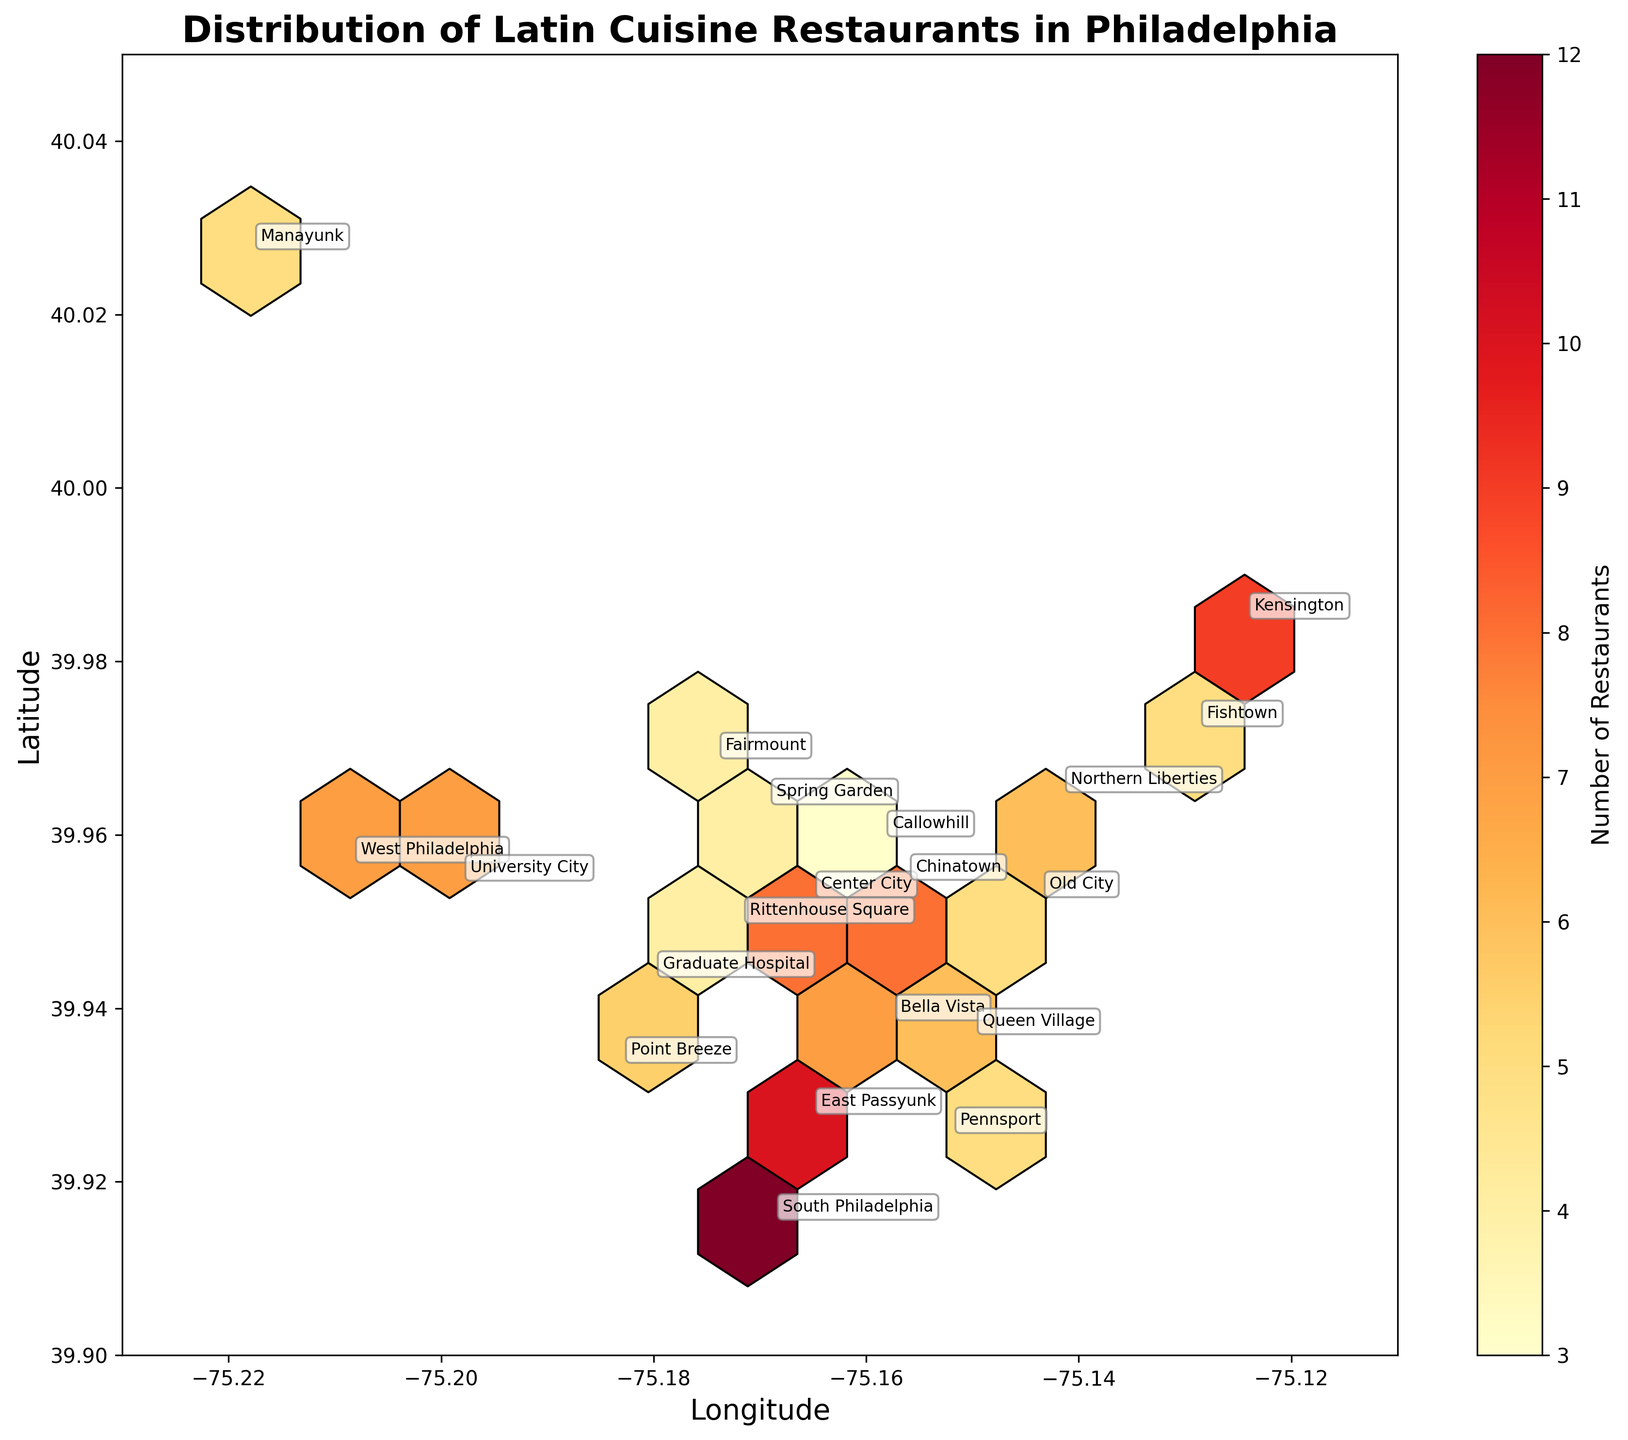How many Latin cuisine restaurants are shown on the map in total? Sum up the "Restaurant_Count" values for all the neighborhoods. They are 8, 12, 5, 6, 7, 4, 5, 9, 7, 10, 6, 4, 5, 3, 8, 6, 5, 4, 7, 5. The total is 8 + 12 + 5 + 6 + 7 + 4 + 5 + 9 + 7 + 10 + 6 + 4 + 5 + 3 + 8 + 6 + 5 + 4 + 7 + 5 = 126.
Answer: 126 What is the range of latitude values shown in the plot? Identify the minimum and maximum latitude values in the data. The minimum latitude is 39.90 (based on the plot's y-axis) and the maximum is 40.05.
Answer: 39.90 to 40.05 Which neighborhood has the largest number of Latin cuisine restaurants? From the data, South Philadelphia has the highest value in the 'Restaurant_Count' column with a count of 12.
Answer: South Philadelphia Which neighborhoods have Latin restaurants with the $$$ price range? Based on the plot annotations, the neighborhoods with the "$$$" price range are Rittenhouse Square and Callowhill.
Answer: Rittenhouse Square and Callowhill What is the color gradient in the hexbin plot representing? The color gradient represents the concentration of the number of restaurants in a given area, with darker colors indicating higher restaurant counts.
Answer: Number of Restaurants How many neighborhoods have restaurant counts between 5 and 10? Identify neighborhoods with 'Restaurant_Count' values between 5 and 10 inclusive. They are Center City (8), Fishtown (5), Northern Liberties (6), West Philadelphia (7), Old City (5), Kensington (9), Bella Vista (7), Queen Village (6), Graduate Hospital (5), Manayunk (5), Chinatown (8), Point Breeze (6), and University City (7), which gives 13 neighborhoods.
Answer: 13 What neighborhood is located at the farthest NE point on the plot? By observing the plot for the most northeastern annotation, it is Kensington.
Answer: Kensington Are there more neighborhoods with Latin restaurants in the "South" or "North" of Philadelphia in the plot? Divide the latitude around the middle of the plot, neighborhoods with "Latitude" less than in the midpoint (39.975) are considered southern, and those above it northern. Summing the counts for each: South has South Philadelphia, West Philadelphia, Rittenhouse Square, Bella Vista, East Passyunk, Queen Village, Point Breeze, Graduate Hospital, Pennsport totaling 8 neighborhoods; North has Center City, Fishtown, Northern Liberties, Old City, Kensington, Fairmount, Manayunk, Callowhill, Chinatown, Spring Garden, University City totaling 11 neighborhoods.
Answer: North How does the distribution of restaurant counts differ between high and low latitude neighborhoods? Compare the areas of higher latitude (e.g., Kensington, Fishtown) and lower latitude (e.g., South Philadelphia, East Passyunk) based on the hex plot. Area with higher latitudes tends to have fewer annotations and lighter hexagons indicating fewer restaurants, while the southern areas have more annotations and darker hexagons showing more dense restaurant distribution.
Answer: Southern areas have more restaurants 